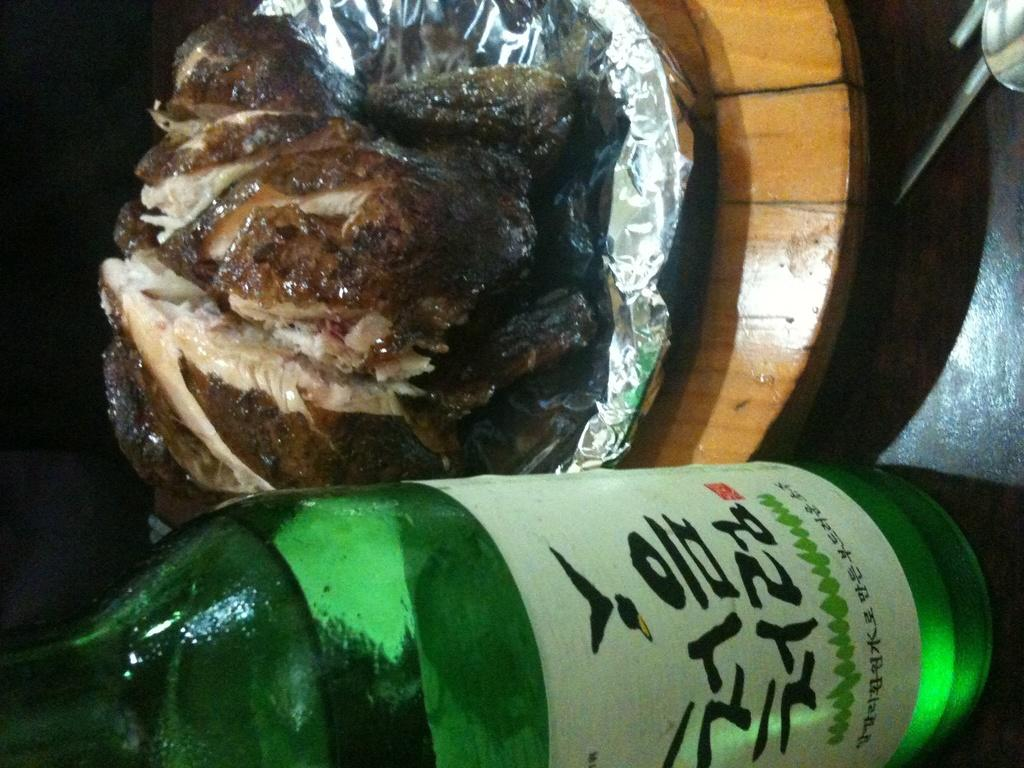What type of beverage container is visible in the image? There is a wine bottle in the image. What is on the plate in the image? There is food on a plate in the image. Are there any giants playing a game of club volleyball in the image? There are no giants or any game of club volleyball present in the image. What type of sheet is covering the food on the plate? There is no sheet covering the food on the plate in the image. 